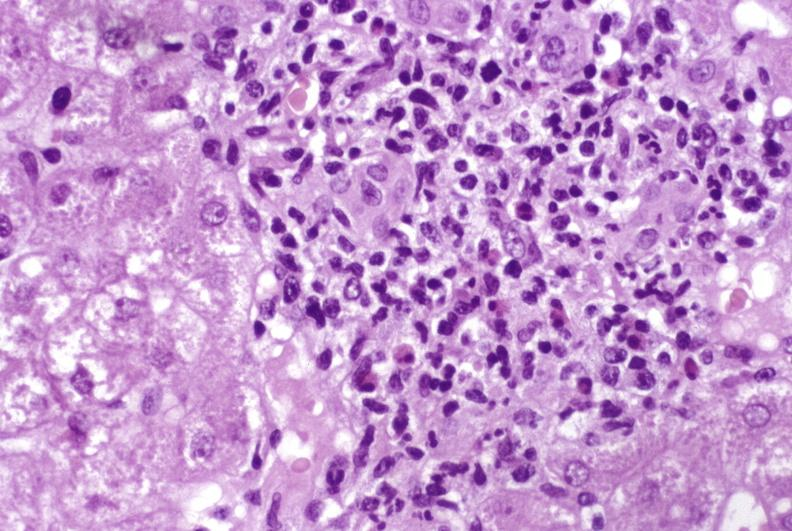s metastatic colon cancer present?
Answer the question using a single word or phrase. No 